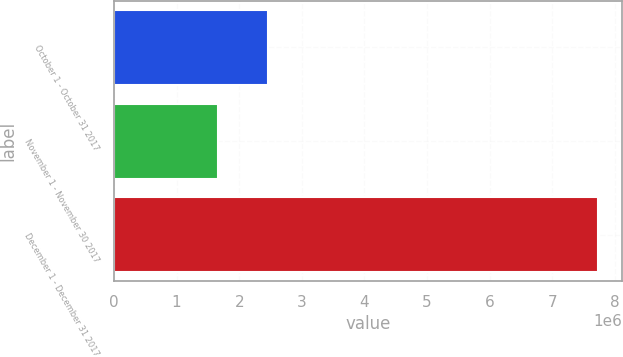<chart> <loc_0><loc_0><loc_500><loc_500><bar_chart><fcel>October 1 - October 31 2017<fcel>November 1 - November 30 2017<fcel>December 1 - December 31 2017<nl><fcel>2.46687e+06<fcel>1.66408e+06<fcel>7.73096e+06<nl></chart> 